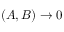Convert formula to latex. <formula><loc_0><loc_0><loc_500><loc_500>( A , B ) \rightarrow 0</formula> 